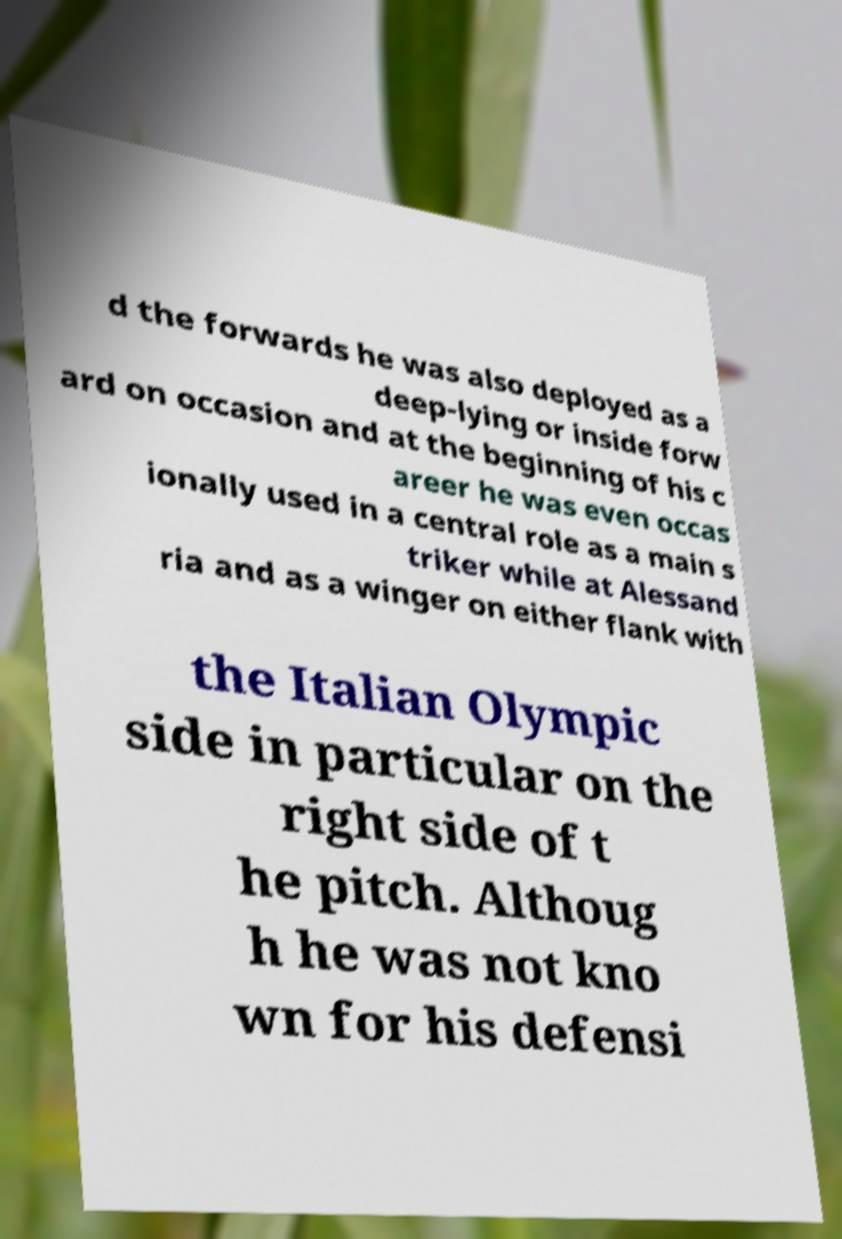Could you assist in decoding the text presented in this image and type it out clearly? d the forwards he was also deployed as a deep-lying or inside forw ard on occasion and at the beginning of his c areer he was even occas ionally used in a central role as a main s triker while at Alessand ria and as a winger on either flank with the Italian Olympic side in particular on the right side of t he pitch. Althoug h he was not kno wn for his defensi 